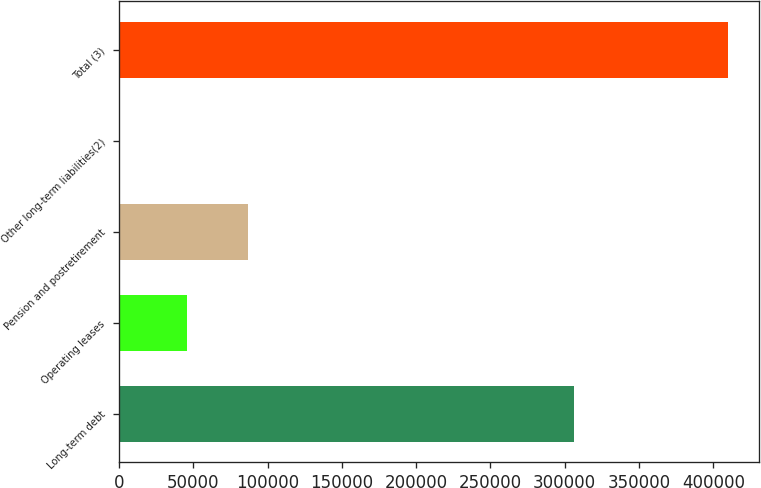Convert chart. <chart><loc_0><loc_0><loc_500><loc_500><bar_chart><fcel>Long-term debt<fcel>Operating leases<fcel>Pension and postretirement<fcel>Other long-term liabilities(2)<fcel>Total (3)<nl><fcel>305949<fcel>45760<fcel>86742.5<fcel>223<fcel>410048<nl></chart> 